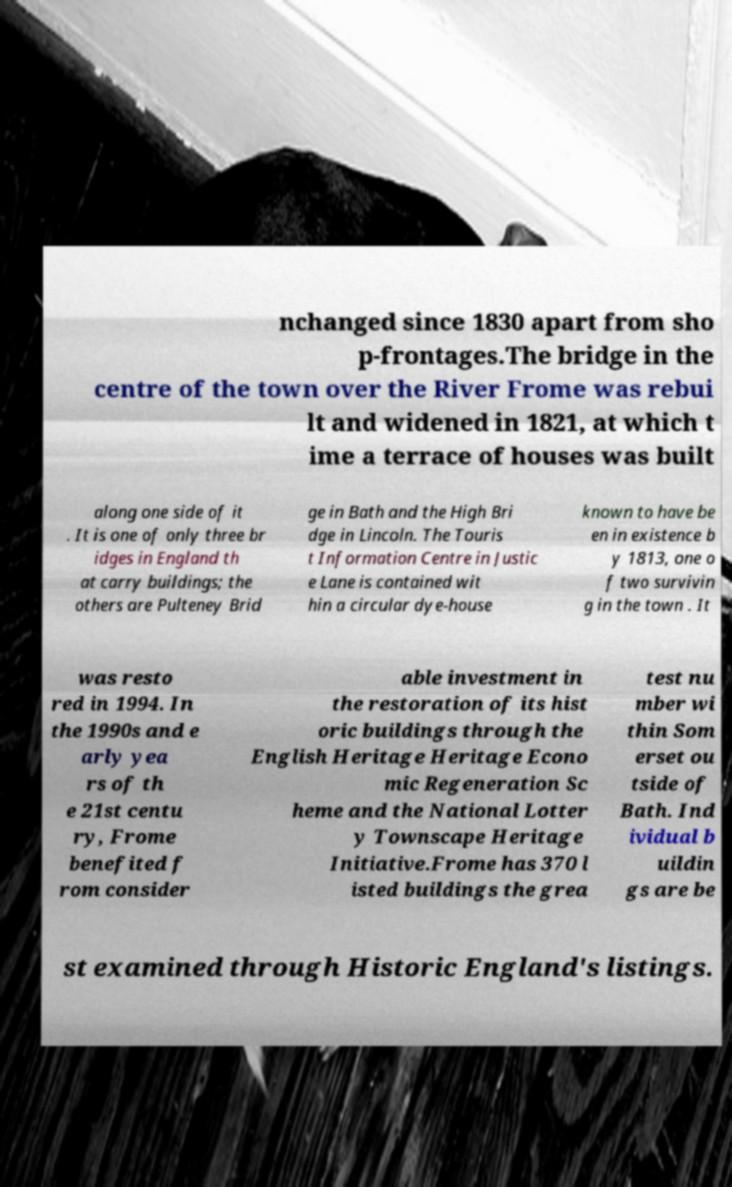Could you extract and type out the text from this image? nchanged since 1830 apart from sho p-frontages.The bridge in the centre of the town over the River Frome was rebui lt and widened in 1821, at which t ime a terrace of houses was built along one side of it . It is one of only three br idges in England th at carry buildings; the others are Pulteney Brid ge in Bath and the High Bri dge in Lincoln. The Touris t Information Centre in Justic e Lane is contained wit hin a circular dye-house known to have be en in existence b y 1813, one o f two survivin g in the town . It was resto red in 1994. In the 1990s and e arly yea rs of th e 21st centu ry, Frome benefited f rom consider able investment in the restoration of its hist oric buildings through the English Heritage Heritage Econo mic Regeneration Sc heme and the National Lotter y Townscape Heritage Initiative.Frome has 370 l isted buildings the grea test nu mber wi thin Som erset ou tside of Bath. Ind ividual b uildin gs are be st examined through Historic England's listings. 